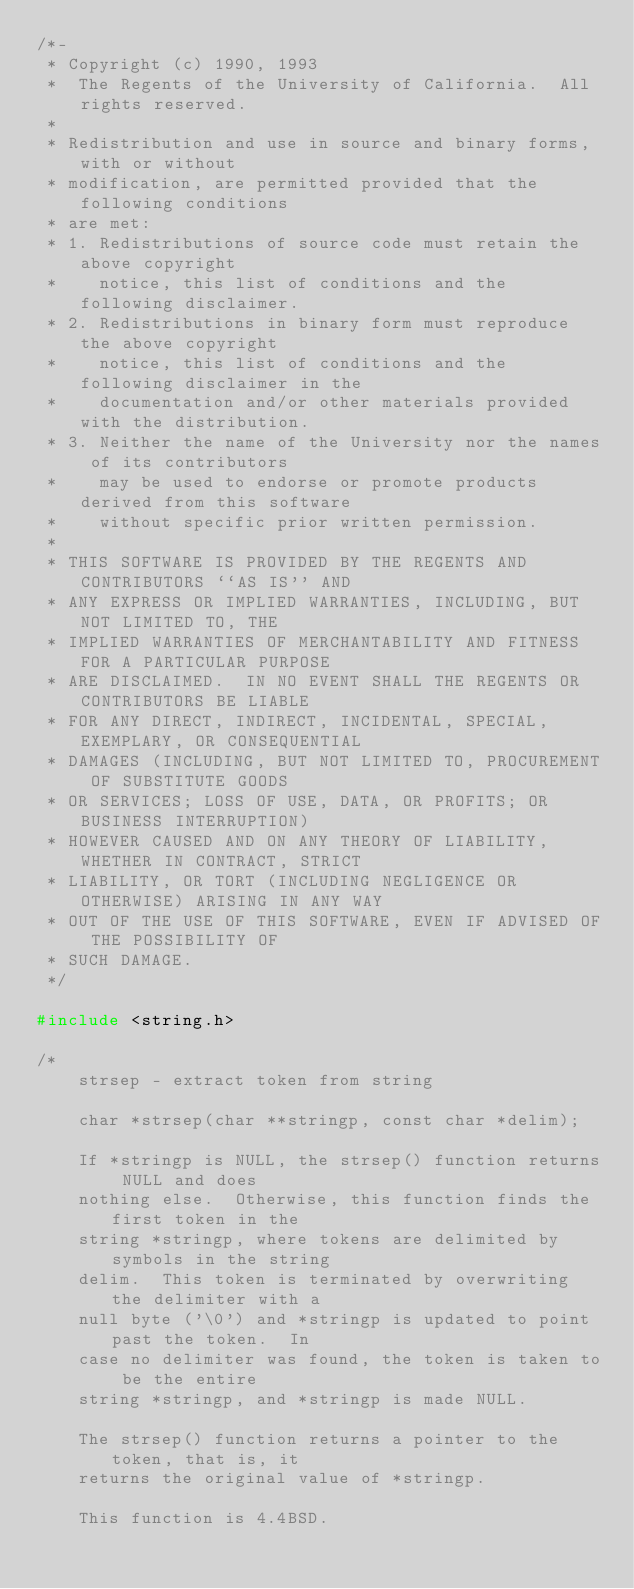<code> <loc_0><loc_0><loc_500><loc_500><_C_>/*-
 * Copyright (c) 1990, 1993
 *	The Regents of the University of California.  All rights reserved.
 *
 * Redistribution and use in source and binary forms, with or without
 * modification, are permitted provided that the following conditions
 * are met:
 * 1. Redistributions of source code must retain the above copyright
 *    notice, this list of conditions and the following disclaimer.
 * 2. Redistributions in binary form must reproduce the above copyright
 *    notice, this list of conditions and the following disclaimer in the
 *    documentation and/or other materials provided with the distribution.
 * 3. Neither the name of the University nor the names of its contributors
 *    may be used to endorse or promote products derived from this software
 *    without specific prior written permission.
 *
 * THIS SOFTWARE IS PROVIDED BY THE REGENTS AND CONTRIBUTORS ``AS IS'' AND
 * ANY EXPRESS OR IMPLIED WARRANTIES, INCLUDING, BUT NOT LIMITED TO, THE
 * IMPLIED WARRANTIES OF MERCHANTABILITY AND FITNESS FOR A PARTICULAR PURPOSE
 * ARE DISCLAIMED.  IN NO EVENT SHALL THE REGENTS OR CONTRIBUTORS BE LIABLE
 * FOR ANY DIRECT, INDIRECT, INCIDENTAL, SPECIAL, EXEMPLARY, OR CONSEQUENTIAL
 * DAMAGES (INCLUDING, BUT NOT LIMITED TO, PROCUREMENT OF SUBSTITUTE GOODS
 * OR SERVICES; LOSS OF USE, DATA, OR PROFITS; OR BUSINESS INTERRUPTION)
 * HOWEVER CAUSED AND ON ANY THEORY OF LIABILITY, WHETHER IN CONTRACT, STRICT
 * LIABILITY, OR TORT (INCLUDING NEGLIGENCE OR OTHERWISE) ARISING IN ANY WAY
 * OUT OF THE USE OF THIS SOFTWARE, EVEN IF ADVISED OF THE POSSIBILITY OF
 * SUCH DAMAGE.
 */

#include <string.h>

/*
    strsep - extract token from string

    char *strsep(char **stringp, const char *delim);

    If *stringp is NULL, the strsep() function returns NULL and does
    nothing else.  Otherwise, this function finds the first token in the
    string *stringp, where tokens are delimited by symbols in the string
    delim.  This token is terminated by overwriting the delimiter with a
    null byte ('\0') and *stringp is updated to point past the token.  In
    case no delimiter was found, the token is taken to be the entire
    string *stringp, and *stringp is made NULL.

    The strsep() function returns a pointer to the token, that is, it
    returns the original value of *stringp.

    This function is 4.4BSD.
</code> 